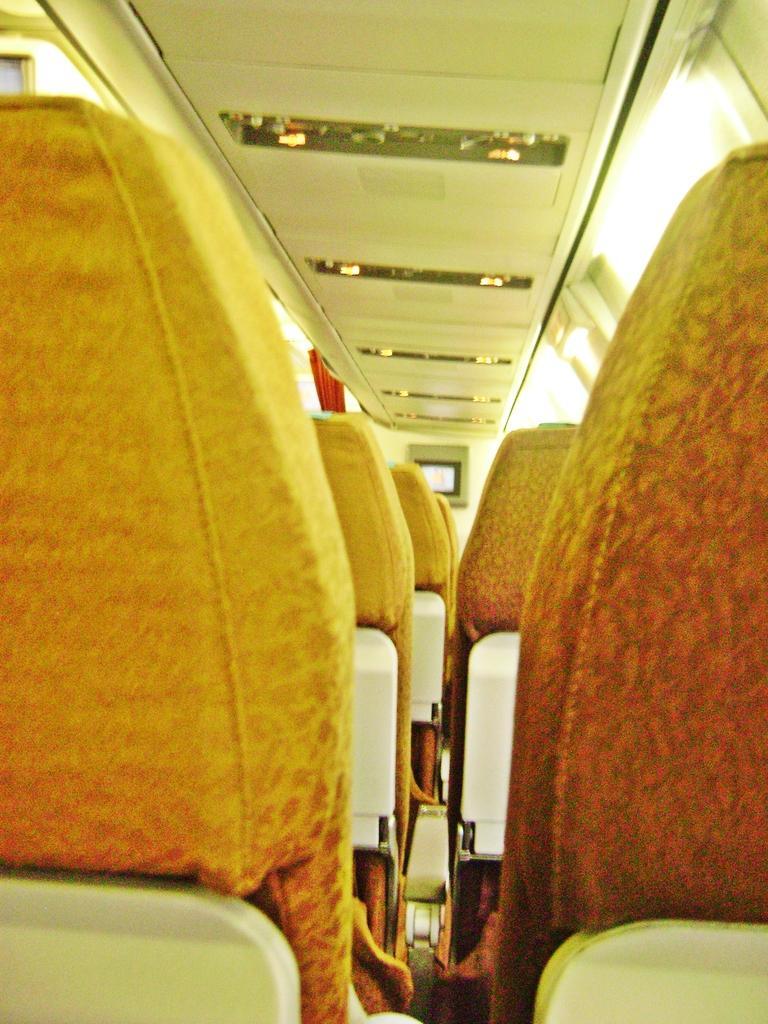Can you describe this image briefly? This image is taken inside of a flight where we can see seats, windows and a screen in the background. 